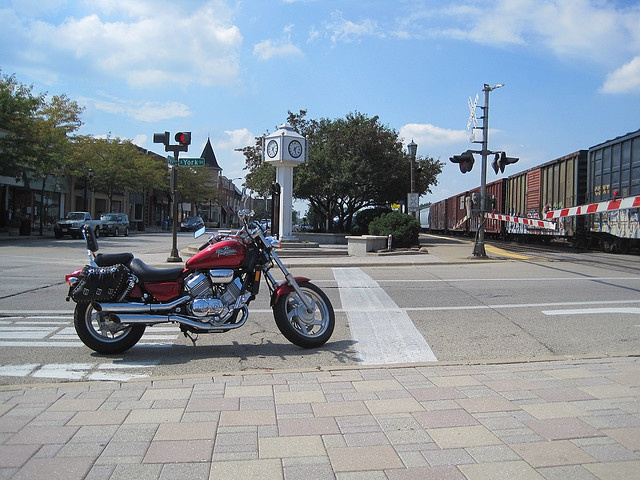Describe the objects in this image and their specific colors. I can see motorcycle in lightblue, black, gray, and darkgray tones, train in lightblue, black, gray, and darkgray tones, truck in lightblue, black, gray, and blue tones, bench in lightblue, gray, darkgray, black, and lightgray tones, and truck in lightblue, black, blue, and gray tones in this image. 